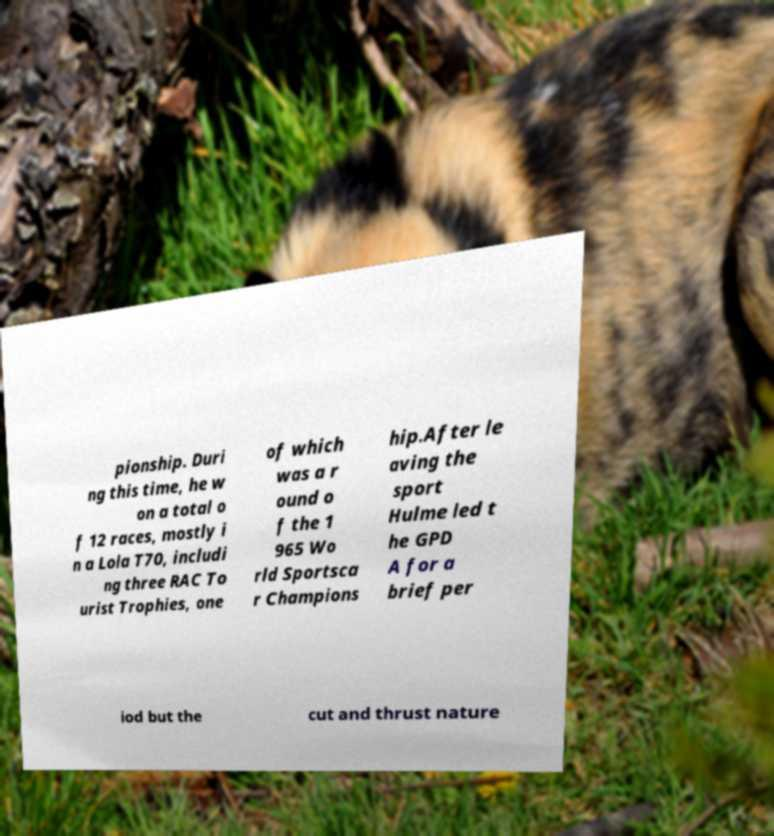Please read and relay the text visible in this image. What does it say? pionship. Duri ng this time, he w on a total o f 12 races, mostly i n a Lola T70, includi ng three RAC To urist Trophies, one of which was a r ound o f the 1 965 Wo rld Sportsca r Champions hip.After le aving the sport Hulme led t he GPD A for a brief per iod but the cut and thrust nature 